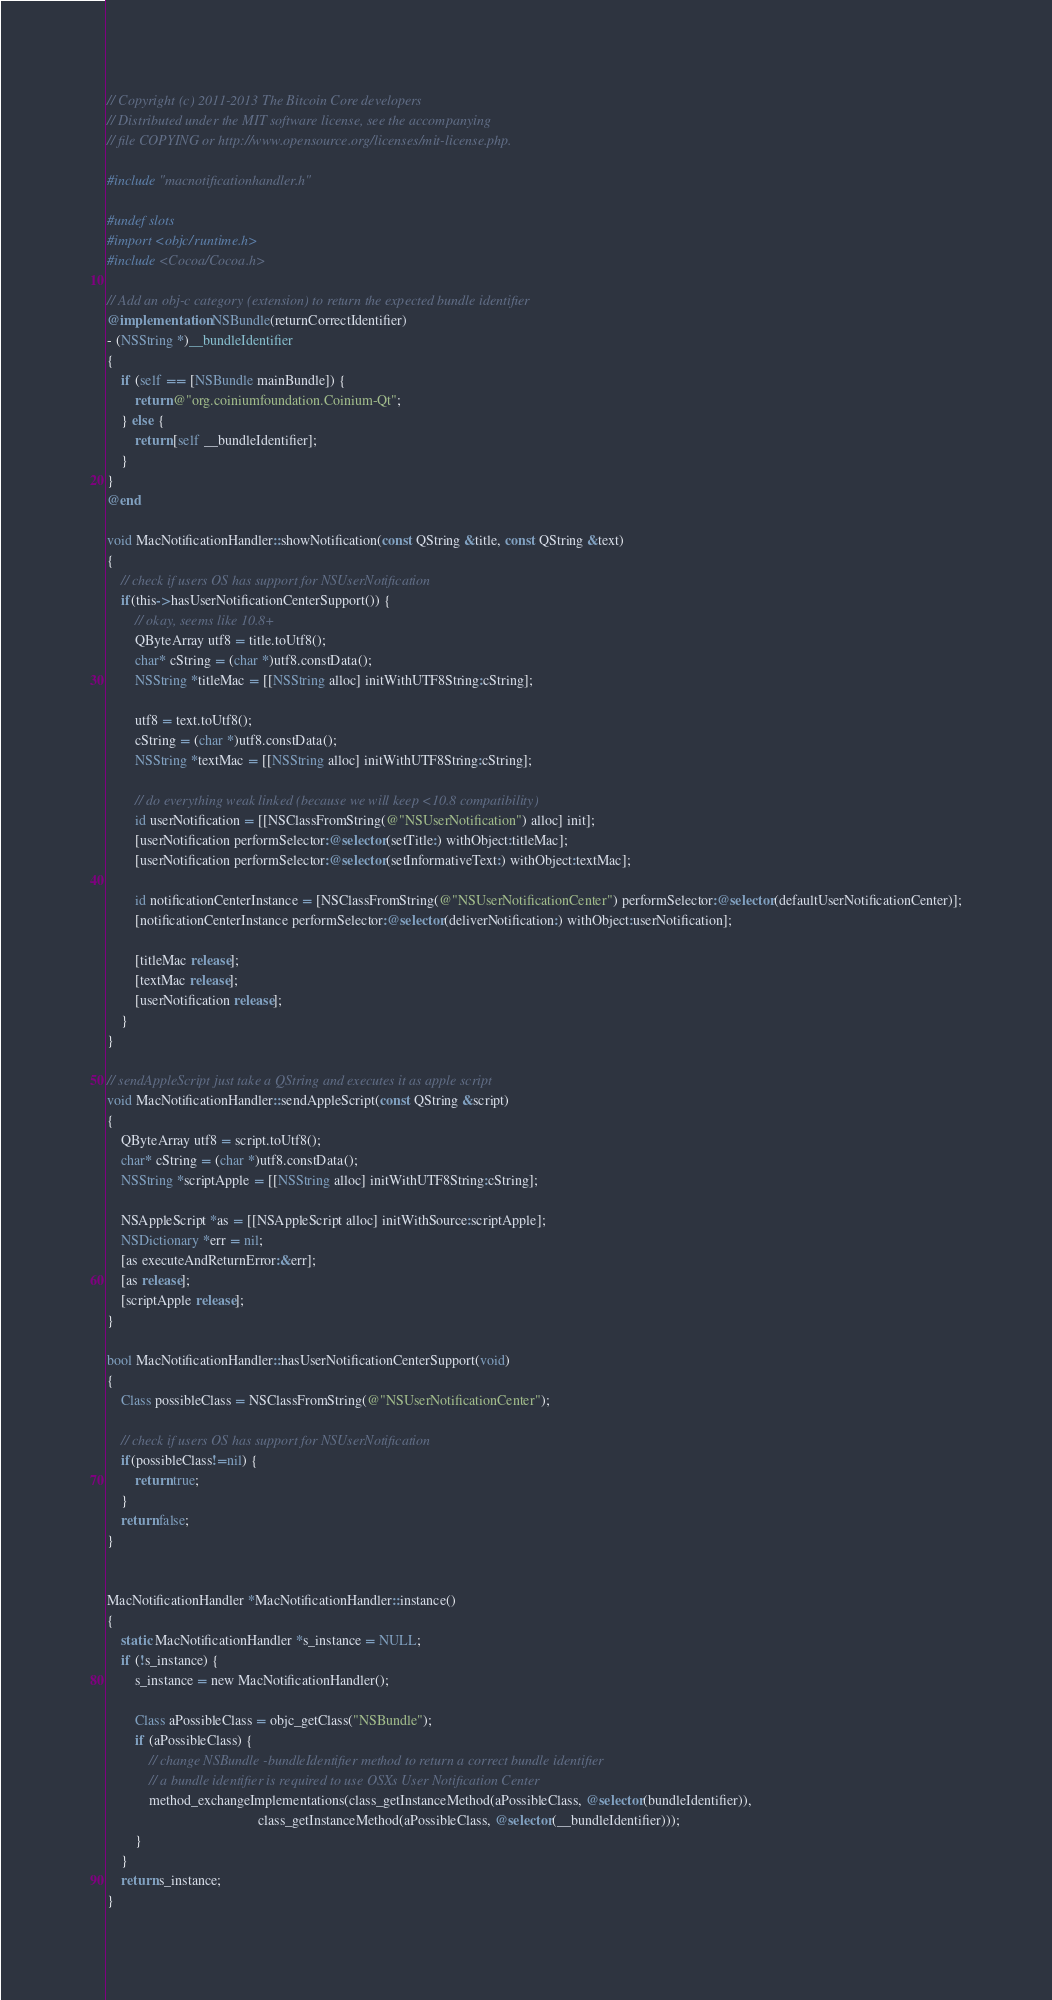Convert code to text. <code><loc_0><loc_0><loc_500><loc_500><_ObjectiveC_>// Copyright (c) 2011-2013 The Bitcoin Core developers
// Distributed under the MIT software license, see the accompanying
// file COPYING or http://www.opensource.org/licenses/mit-license.php.

#include "macnotificationhandler.h"

#undef slots
#import <objc/runtime.h>
#include <Cocoa/Cocoa.h>

// Add an obj-c category (extension) to return the expected bundle identifier
@implementation NSBundle(returnCorrectIdentifier)
- (NSString *)__bundleIdentifier
{
    if (self == [NSBundle mainBundle]) {
        return @"org.coiniumfoundation.Coinium-Qt";
    } else {
        return [self __bundleIdentifier];
    }
}
@end

void MacNotificationHandler::showNotification(const QString &title, const QString &text)
{
    // check if users OS has support for NSUserNotification
    if(this->hasUserNotificationCenterSupport()) {
        // okay, seems like 10.8+
        QByteArray utf8 = title.toUtf8();
        char* cString = (char *)utf8.constData();
        NSString *titleMac = [[NSString alloc] initWithUTF8String:cString];

        utf8 = text.toUtf8();
        cString = (char *)utf8.constData();
        NSString *textMac = [[NSString alloc] initWithUTF8String:cString];

        // do everything weak linked (because we will keep <10.8 compatibility)
        id userNotification = [[NSClassFromString(@"NSUserNotification") alloc] init];
        [userNotification performSelector:@selector(setTitle:) withObject:titleMac];
        [userNotification performSelector:@selector(setInformativeText:) withObject:textMac];

        id notificationCenterInstance = [NSClassFromString(@"NSUserNotificationCenter") performSelector:@selector(defaultUserNotificationCenter)];
        [notificationCenterInstance performSelector:@selector(deliverNotification:) withObject:userNotification];

        [titleMac release];
        [textMac release];
        [userNotification release];
    }
}

// sendAppleScript just take a QString and executes it as apple script
void MacNotificationHandler::sendAppleScript(const QString &script)
{
    QByteArray utf8 = script.toUtf8();
    char* cString = (char *)utf8.constData();
    NSString *scriptApple = [[NSString alloc] initWithUTF8String:cString];

    NSAppleScript *as = [[NSAppleScript alloc] initWithSource:scriptApple];
    NSDictionary *err = nil;
    [as executeAndReturnError:&err];
    [as release];
    [scriptApple release];
}

bool MacNotificationHandler::hasUserNotificationCenterSupport(void)
{
    Class possibleClass = NSClassFromString(@"NSUserNotificationCenter");

    // check if users OS has support for NSUserNotification
    if(possibleClass!=nil) {
        return true;
    }
    return false;
}


MacNotificationHandler *MacNotificationHandler::instance()
{
    static MacNotificationHandler *s_instance = NULL;
    if (!s_instance) {
        s_instance = new MacNotificationHandler();
        
        Class aPossibleClass = objc_getClass("NSBundle");
        if (aPossibleClass) {
            // change NSBundle -bundleIdentifier method to return a correct bundle identifier
            // a bundle identifier is required to use OSXs User Notification Center
            method_exchangeImplementations(class_getInstanceMethod(aPossibleClass, @selector(bundleIdentifier)),
                                           class_getInstanceMethod(aPossibleClass, @selector(__bundleIdentifier)));
        }
    }
    return s_instance;
}
</code> 